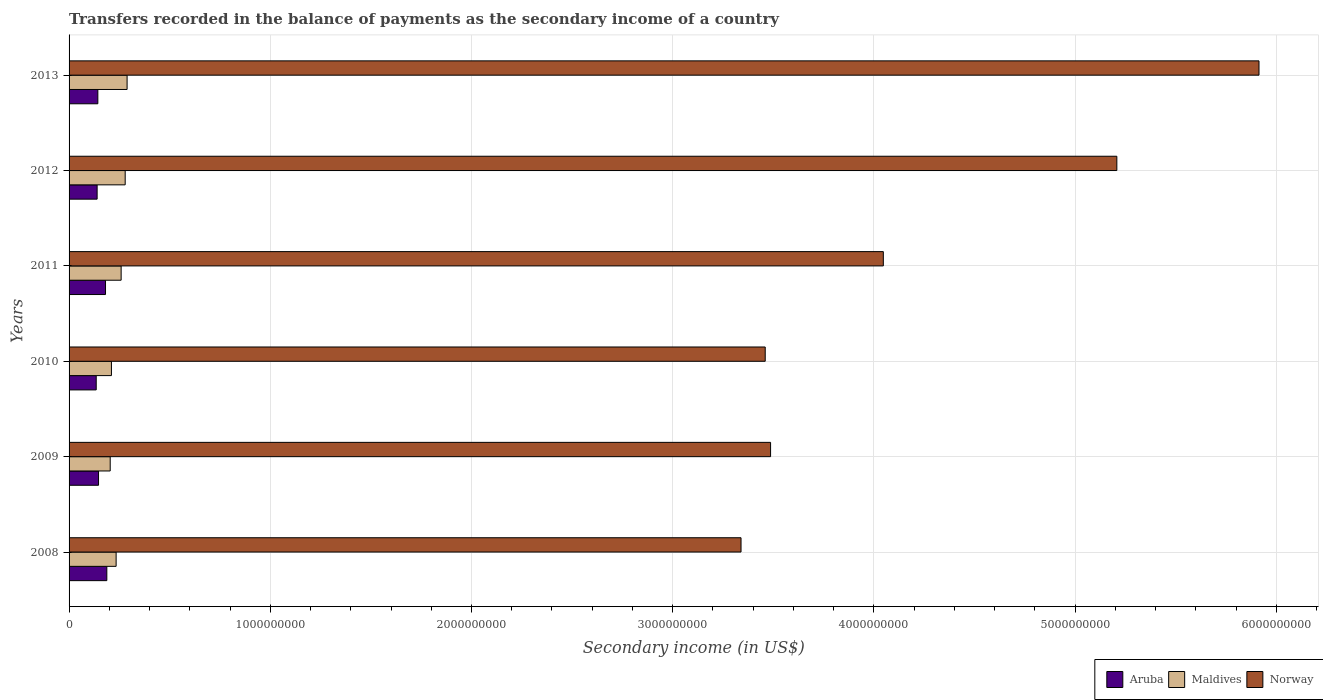Are the number of bars per tick equal to the number of legend labels?
Your response must be concise. Yes. How many bars are there on the 1st tick from the top?
Give a very brief answer. 3. How many bars are there on the 1st tick from the bottom?
Keep it short and to the point. 3. In how many cases, is the number of bars for a given year not equal to the number of legend labels?
Your response must be concise. 0. What is the secondary income of in Norway in 2010?
Provide a succinct answer. 3.46e+09. Across all years, what is the maximum secondary income of in Maldives?
Your response must be concise. 2.88e+08. Across all years, what is the minimum secondary income of in Aruba?
Offer a very short reply. 1.35e+08. In which year was the secondary income of in Maldives maximum?
Offer a terse response. 2013. In which year was the secondary income of in Aruba minimum?
Ensure brevity in your answer.  2010. What is the total secondary income of in Maldives in the graph?
Provide a succinct answer. 1.47e+09. What is the difference between the secondary income of in Aruba in 2008 and that in 2010?
Offer a very short reply. 5.27e+07. What is the difference between the secondary income of in Maldives in 2009 and the secondary income of in Aruba in 2008?
Offer a terse response. 1.68e+07. What is the average secondary income of in Maldives per year?
Your response must be concise. 2.46e+08. In the year 2013, what is the difference between the secondary income of in Maldives and secondary income of in Aruba?
Provide a succinct answer. 1.45e+08. What is the ratio of the secondary income of in Aruba in 2008 to that in 2011?
Provide a short and direct response. 1.04. Is the difference between the secondary income of in Maldives in 2008 and 2009 greater than the difference between the secondary income of in Aruba in 2008 and 2009?
Provide a short and direct response. No. What is the difference between the highest and the second highest secondary income of in Maldives?
Ensure brevity in your answer.  9.48e+06. What is the difference between the highest and the lowest secondary income of in Aruba?
Your response must be concise. 5.27e+07. In how many years, is the secondary income of in Norway greater than the average secondary income of in Norway taken over all years?
Your answer should be very brief. 2. Is the sum of the secondary income of in Aruba in 2012 and 2013 greater than the maximum secondary income of in Maldives across all years?
Offer a very short reply. No. What does the 2nd bar from the top in 2012 represents?
Provide a short and direct response. Maldives. What does the 2nd bar from the bottom in 2012 represents?
Offer a terse response. Maldives. Is it the case that in every year, the sum of the secondary income of in Norway and secondary income of in Maldives is greater than the secondary income of in Aruba?
Keep it short and to the point. Yes. How many years are there in the graph?
Your response must be concise. 6. What is the difference between two consecutive major ticks on the X-axis?
Your response must be concise. 1.00e+09. Does the graph contain grids?
Your answer should be very brief. Yes. Where does the legend appear in the graph?
Your response must be concise. Bottom right. How many legend labels are there?
Keep it short and to the point. 3. How are the legend labels stacked?
Offer a very short reply. Horizontal. What is the title of the graph?
Provide a succinct answer. Transfers recorded in the balance of payments as the secondary income of a country. Does "Turkey" appear as one of the legend labels in the graph?
Your answer should be compact. No. What is the label or title of the X-axis?
Your response must be concise. Secondary income (in US$). What is the Secondary income (in US$) in Aruba in 2008?
Ensure brevity in your answer.  1.88e+08. What is the Secondary income (in US$) in Maldives in 2008?
Ensure brevity in your answer.  2.34e+08. What is the Secondary income (in US$) in Norway in 2008?
Give a very brief answer. 3.34e+09. What is the Secondary income (in US$) of Aruba in 2009?
Make the answer very short. 1.46e+08. What is the Secondary income (in US$) in Maldives in 2009?
Your answer should be very brief. 2.04e+08. What is the Secondary income (in US$) in Norway in 2009?
Offer a very short reply. 3.49e+09. What is the Secondary income (in US$) in Aruba in 2010?
Give a very brief answer. 1.35e+08. What is the Secondary income (in US$) in Maldives in 2010?
Offer a terse response. 2.11e+08. What is the Secondary income (in US$) of Norway in 2010?
Offer a very short reply. 3.46e+09. What is the Secondary income (in US$) in Aruba in 2011?
Offer a very short reply. 1.81e+08. What is the Secondary income (in US$) in Maldives in 2011?
Ensure brevity in your answer.  2.59e+08. What is the Secondary income (in US$) in Norway in 2011?
Your response must be concise. 4.05e+09. What is the Secondary income (in US$) in Aruba in 2012?
Provide a short and direct response. 1.39e+08. What is the Secondary income (in US$) of Maldives in 2012?
Your answer should be very brief. 2.79e+08. What is the Secondary income (in US$) in Norway in 2012?
Give a very brief answer. 5.21e+09. What is the Secondary income (in US$) of Aruba in 2013?
Provide a short and direct response. 1.43e+08. What is the Secondary income (in US$) of Maldives in 2013?
Your response must be concise. 2.88e+08. What is the Secondary income (in US$) in Norway in 2013?
Offer a very short reply. 5.91e+09. Across all years, what is the maximum Secondary income (in US$) of Aruba?
Your response must be concise. 1.88e+08. Across all years, what is the maximum Secondary income (in US$) in Maldives?
Give a very brief answer. 2.88e+08. Across all years, what is the maximum Secondary income (in US$) in Norway?
Provide a short and direct response. 5.91e+09. Across all years, what is the minimum Secondary income (in US$) in Aruba?
Offer a terse response. 1.35e+08. Across all years, what is the minimum Secondary income (in US$) in Maldives?
Your answer should be very brief. 2.04e+08. Across all years, what is the minimum Secondary income (in US$) of Norway?
Your response must be concise. 3.34e+09. What is the total Secondary income (in US$) in Aruba in the graph?
Your answer should be compact. 9.33e+08. What is the total Secondary income (in US$) of Maldives in the graph?
Provide a short and direct response. 1.47e+09. What is the total Secondary income (in US$) in Norway in the graph?
Your answer should be very brief. 2.55e+1. What is the difference between the Secondary income (in US$) of Aruba in 2008 and that in 2009?
Keep it short and to the point. 4.12e+07. What is the difference between the Secondary income (in US$) in Maldives in 2008 and that in 2009?
Your response must be concise. 2.94e+07. What is the difference between the Secondary income (in US$) in Norway in 2008 and that in 2009?
Provide a short and direct response. -1.47e+08. What is the difference between the Secondary income (in US$) in Aruba in 2008 and that in 2010?
Your answer should be very brief. 5.27e+07. What is the difference between the Secondary income (in US$) of Maldives in 2008 and that in 2010?
Offer a very short reply. 2.33e+07. What is the difference between the Secondary income (in US$) in Norway in 2008 and that in 2010?
Provide a short and direct response. -1.20e+08. What is the difference between the Secondary income (in US$) in Aruba in 2008 and that in 2011?
Make the answer very short. 6.54e+06. What is the difference between the Secondary income (in US$) in Maldives in 2008 and that in 2011?
Your answer should be compact. -2.50e+07. What is the difference between the Secondary income (in US$) in Norway in 2008 and that in 2011?
Ensure brevity in your answer.  -7.07e+08. What is the difference between the Secondary income (in US$) in Aruba in 2008 and that in 2012?
Offer a terse response. 4.82e+07. What is the difference between the Secondary income (in US$) of Maldives in 2008 and that in 2012?
Give a very brief answer. -4.51e+07. What is the difference between the Secondary income (in US$) of Norway in 2008 and that in 2012?
Make the answer very short. -1.87e+09. What is the difference between the Secondary income (in US$) in Aruba in 2008 and that in 2013?
Your answer should be compact. 4.46e+07. What is the difference between the Secondary income (in US$) of Maldives in 2008 and that in 2013?
Your answer should be compact. -5.45e+07. What is the difference between the Secondary income (in US$) in Norway in 2008 and that in 2013?
Provide a short and direct response. -2.57e+09. What is the difference between the Secondary income (in US$) of Aruba in 2009 and that in 2010?
Give a very brief answer. 1.15e+07. What is the difference between the Secondary income (in US$) in Maldives in 2009 and that in 2010?
Offer a very short reply. -6.12e+06. What is the difference between the Secondary income (in US$) of Norway in 2009 and that in 2010?
Give a very brief answer. 2.66e+07. What is the difference between the Secondary income (in US$) in Aruba in 2009 and that in 2011?
Make the answer very short. -3.47e+07. What is the difference between the Secondary income (in US$) of Maldives in 2009 and that in 2011?
Provide a short and direct response. -5.44e+07. What is the difference between the Secondary income (in US$) of Norway in 2009 and that in 2011?
Offer a terse response. -5.60e+08. What is the difference between the Secondary income (in US$) of Aruba in 2009 and that in 2012?
Make the answer very short. 6.98e+06. What is the difference between the Secondary income (in US$) of Maldives in 2009 and that in 2012?
Give a very brief answer. -7.45e+07. What is the difference between the Secondary income (in US$) of Norway in 2009 and that in 2012?
Make the answer very short. -1.72e+09. What is the difference between the Secondary income (in US$) of Aruba in 2009 and that in 2013?
Your response must be concise. 3.41e+06. What is the difference between the Secondary income (in US$) of Maldives in 2009 and that in 2013?
Give a very brief answer. -8.40e+07. What is the difference between the Secondary income (in US$) in Norway in 2009 and that in 2013?
Your answer should be very brief. -2.43e+09. What is the difference between the Secondary income (in US$) of Aruba in 2010 and that in 2011?
Ensure brevity in your answer.  -4.62e+07. What is the difference between the Secondary income (in US$) in Maldives in 2010 and that in 2011?
Make the answer very short. -4.83e+07. What is the difference between the Secondary income (in US$) in Norway in 2010 and that in 2011?
Your answer should be compact. -5.87e+08. What is the difference between the Secondary income (in US$) of Aruba in 2010 and that in 2012?
Offer a very short reply. -4.53e+06. What is the difference between the Secondary income (in US$) of Maldives in 2010 and that in 2012?
Provide a succinct answer. -6.84e+07. What is the difference between the Secondary income (in US$) in Norway in 2010 and that in 2012?
Your answer should be compact. -1.75e+09. What is the difference between the Secondary income (in US$) in Aruba in 2010 and that in 2013?
Your answer should be compact. -8.10e+06. What is the difference between the Secondary income (in US$) of Maldives in 2010 and that in 2013?
Your answer should be compact. -7.79e+07. What is the difference between the Secondary income (in US$) in Norway in 2010 and that in 2013?
Offer a terse response. -2.45e+09. What is the difference between the Secondary income (in US$) in Aruba in 2011 and that in 2012?
Your answer should be very brief. 4.17e+07. What is the difference between the Secondary income (in US$) in Maldives in 2011 and that in 2012?
Provide a short and direct response. -2.01e+07. What is the difference between the Secondary income (in US$) in Norway in 2011 and that in 2012?
Offer a very short reply. -1.16e+09. What is the difference between the Secondary income (in US$) in Aruba in 2011 and that in 2013?
Your answer should be compact. 3.81e+07. What is the difference between the Secondary income (in US$) of Maldives in 2011 and that in 2013?
Provide a short and direct response. -2.96e+07. What is the difference between the Secondary income (in US$) in Norway in 2011 and that in 2013?
Make the answer very short. -1.87e+09. What is the difference between the Secondary income (in US$) in Aruba in 2012 and that in 2013?
Provide a short and direct response. -3.58e+06. What is the difference between the Secondary income (in US$) in Maldives in 2012 and that in 2013?
Keep it short and to the point. -9.48e+06. What is the difference between the Secondary income (in US$) of Norway in 2012 and that in 2013?
Make the answer very short. -7.07e+08. What is the difference between the Secondary income (in US$) of Aruba in 2008 and the Secondary income (in US$) of Maldives in 2009?
Provide a succinct answer. -1.68e+07. What is the difference between the Secondary income (in US$) of Aruba in 2008 and the Secondary income (in US$) of Norway in 2009?
Your answer should be very brief. -3.30e+09. What is the difference between the Secondary income (in US$) of Maldives in 2008 and the Secondary income (in US$) of Norway in 2009?
Offer a terse response. -3.25e+09. What is the difference between the Secondary income (in US$) in Aruba in 2008 and the Secondary income (in US$) in Maldives in 2010?
Offer a terse response. -2.29e+07. What is the difference between the Secondary income (in US$) of Aruba in 2008 and the Secondary income (in US$) of Norway in 2010?
Provide a succinct answer. -3.27e+09. What is the difference between the Secondary income (in US$) of Maldives in 2008 and the Secondary income (in US$) of Norway in 2010?
Your answer should be very brief. -3.23e+09. What is the difference between the Secondary income (in US$) in Aruba in 2008 and the Secondary income (in US$) in Maldives in 2011?
Ensure brevity in your answer.  -7.12e+07. What is the difference between the Secondary income (in US$) in Aruba in 2008 and the Secondary income (in US$) in Norway in 2011?
Your response must be concise. -3.86e+09. What is the difference between the Secondary income (in US$) of Maldives in 2008 and the Secondary income (in US$) of Norway in 2011?
Offer a terse response. -3.81e+09. What is the difference between the Secondary income (in US$) in Aruba in 2008 and the Secondary income (in US$) in Maldives in 2012?
Give a very brief answer. -9.13e+07. What is the difference between the Secondary income (in US$) in Aruba in 2008 and the Secondary income (in US$) in Norway in 2012?
Provide a short and direct response. -5.02e+09. What is the difference between the Secondary income (in US$) in Maldives in 2008 and the Secondary income (in US$) in Norway in 2012?
Make the answer very short. -4.97e+09. What is the difference between the Secondary income (in US$) in Aruba in 2008 and the Secondary income (in US$) in Maldives in 2013?
Your answer should be very brief. -1.01e+08. What is the difference between the Secondary income (in US$) of Aruba in 2008 and the Secondary income (in US$) of Norway in 2013?
Give a very brief answer. -5.73e+09. What is the difference between the Secondary income (in US$) of Maldives in 2008 and the Secondary income (in US$) of Norway in 2013?
Offer a very short reply. -5.68e+09. What is the difference between the Secondary income (in US$) in Aruba in 2009 and the Secondary income (in US$) in Maldives in 2010?
Your response must be concise. -6.41e+07. What is the difference between the Secondary income (in US$) in Aruba in 2009 and the Secondary income (in US$) in Norway in 2010?
Your answer should be very brief. -3.31e+09. What is the difference between the Secondary income (in US$) in Maldives in 2009 and the Secondary income (in US$) in Norway in 2010?
Offer a very short reply. -3.26e+09. What is the difference between the Secondary income (in US$) of Aruba in 2009 and the Secondary income (in US$) of Maldives in 2011?
Provide a succinct answer. -1.12e+08. What is the difference between the Secondary income (in US$) of Aruba in 2009 and the Secondary income (in US$) of Norway in 2011?
Provide a short and direct response. -3.90e+09. What is the difference between the Secondary income (in US$) of Maldives in 2009 and the Secondary income (in US$) of Norway in 2011?
Ensure brevity in your answer.  -3.84e+09. What is the difference between the Secondary income (in US$) of Aruba in 2009 and the Secondary income (in US$) of Maldives in 2012?
Provide a short and direct response. -1.32e+08. What is the difference between the Secondary income (in US$) in Aruba in 2009 and the Secondary income (in US$) in Norway in 2012?
Your answer should be very brief. -5.06e+09. What is the difference between the Secondary income (in US$) of Maldives in 2009 and the Secondary income (in US$) of Norway in 2012?
Make the answer very short. -5.00e+09. What is the difference between the Secondary income (in US$) of Aruba in 2009 and the Secondary income (in US$) of Maldives in 2013?
Make the answer very short. -1.42e+08. What is the difference between the Secondary income (in US$) of Aruba in 2009 and the Secondary income (in US$) of Norway in 2013?
Your response must be concise. -5.77e+09. What is the difference between the Secondary income (in US$) in Maldives in 2009 and the Secondary income (in US$) in Norway in 2013?
Your answer should be compact. -5.71e+09. What is the difference between the Secondary income (in US$) in Aruba in 2010 and the Secondary income (in US$) in Maldives in 2011?
Provide a short and direct response. -1.24e+08. What is the difference between the Secondary income (in US$) of Aruba in 2010 and the Secondary income (in US$) of Norway in 2011?
Offer a terse response. -3.91e+09. What is the difference between the Secondary income (in US$) in Maldives in 2010 and the Secondary income (in US$) in Norway in 2011?
Ensure brevity in your answer.  -3.84e+09. What is the difference between the Secondary income (in US$) of Aruba in 2010 and the Secondary income (in US$) of Maldives in 2012?
Your response must be concise. -1.44e+08. What is the difference between the Secondary income (in US$) of Aruba in 2010 and the Secondary income (in US$) of Norway in 2012?
Your answer should be compact. -5.07e+09. What is the difference between the Secondary income (in US$) of Maldives in 2010 and the Secondary income (in US$) of Norway in 2012?
Your answer should be very brief. -5.00e+09. What is the difference between the Secondary income (in US$) in Aruba in 2010 and the Secondary income (in US$) in Maldives in 2013?
Ensure brevity in your answer.  -1.53e+08. What is the difference between the Secondary income (in US$) in Aruba in 2010 and the Secondary income (in US$) in Norway in 2013?
Provide a succinct answer. -5.78e+09. What is the difference between the Secondary income (in US$) of Maldives in 2010 and the Secondary income (in US$) of Norway in 2013?
Your answer should be compact. -5.70e+09. What is the difference between the Secondary income (in US$) in Aruba in 2011 and the Secondary income (in US$) in Maldives in 2012?
Keep it short and to the point. -9.78e+07. What is the difference between the Secondary income (in US$) of Aruba in 2011 and the Secondary income (in US$) of Norway in 2012?
Offer a very short reply. -5.03e+09. What is the difference between the Secondary income (in US$) of Maldives in 2011 and the Secondary income (in US$) of Norway in 2012?
Make the answer very short. -4.95e+09. What is the difference between the Secondary income (in US$) of Aruba in 2011 and the Secondary income (in US$) of Maldives in 2013?
Your answer should be very brief. -1.07e+08. What is the difference between the Secondary income (in US$) in Aruba in 2011 and the Secondary income (in US$) in Norway in 2013?
Your answer should be compact. -5.73e+09. What is the difference between the Secondary income (in US$) in Maldives in 2011 and the Secondary income (in US$) in Norway in 2013?
Your answer should be very brief. -5.66e+09. What is the difference between the Secondary income (in US$) in Aruba in 2012 and the Secondary income (in US$) in Maldives in 2013?
Make the answer very short. -1.49e+08. What is the difference between the Secondary income (in US$) in Aruba in 2012 and the Secondary income (in US$) in Norway in 2013?
Your answer should be very brief. -5.77e+09. What is the difference between the Secondary income (in US$) of Maldives in 2012 and the Secondary income (in US$) of Norway in 2013?
Your response must be concise. -5.64e+09. What is the average Secondary income (in US$) of Aruba per year?
Make the answer very short. 1.55e+08. What is the average Secondary income (in US$) of Maldives per year?
Keep it short and to the point. 2.46e+08. What is the average Secondary income (in US$) of Norway per year?
Provide a short and direct response. 4.24e+09. In the year 2008, what is the difference between the Secondary income (in US$) in Aruba and Secondary income (in US$) in Maldives?
Your answer should be compact. -4.62e+07. In the year 2008, what is the difference between the Secondary income (in US$) in Aruba and Secondary income (in US$) in Norway?
Your answer should be very brief. -3.15e+09. In the year 2008, what is the difference between the Secondary income (in US$) of Maldives and Secondary income (in US$) of Norway?
Make the answer very short. -3.11e+09. In the year 2009, what is the difference between the Secondary income (in US$) in Aruba and Secondary income (in US$) in Maldives?
Give a very brief answer. -5.80e+07. In the year 2009, what is the difference between the Secondary income (in US$) of Aruba and Secondary income (in US$) of Norway?
Offer a terse response. -3.34e+09. In the year 2009, what is the difference between the Secondary income (in US$) of Maldives and Secondary income (in US$) of Norway?
Your answer should be very brief. -3.28e+09. In the year 2010, what is the difference between the Secondary income (in US$) of Aruba and Secondary income (in US$) of Maldives?
Offer a terse response. -7.56e+07. In the year 2010, what is the difference between the Secondary income (in US$) of Aruba and Secondary income (in US$) of Norway?
Give a very brief answer. -3.33e+09. In the year 2010, what is the difference between the Secondary income (in US$) of Maldives and Secondary income (in US$) of Norway?
Offer a terse response. -3.25e+09. In the year 2011, what is the difference between the Secondary income (in US$) of Aruba and Secondary income (in US$) of Maldives?
Your response must be concise. -7.77e+07. In the year 2011, what is the difference between the Secondary income (in US$) of Aruba and Secondary income (in US$) of Norway?
Offer a terse response. -3.87e+09. In the year 2011, what is the difference between the Secondary income (in US$) of Maldives and Secondary income (in US$) of Norway?
Your answer should be compact. -3.79e+09. In the year 2012, what is the difference between the Secondary income (in US$) of Aruba and Secondary income (in US$) of Maldives?
Your response must be concise. -1.39e+08. In the year 2012, what is the difference between the Secondary income (in US$) in Aruba and Secondary income (in US$) in Norway?
Provide a succinct answer. -5.07e+09. In the year 2012, what is the difference between the Secondary income (in US$) of Maldives and Secondary income (in US$) of Norway?
Provide a succinct answer. -4.93e+09. In the year 2013, what is the difference between the Secondary income (in US$) in Aruba and Secondary income (in US$) in Maldives?
Offer a terse response. -1.45e+08. In the year 2013, what is the difference between the Secondary income (in US$) in Aruba and Secondary income (in US$) in Norway?
Your answer should be very brief. -5.77e+09. In the year 2013, what is the difference between the Secondary income (in US$) of Maldives and Secondary income (in US$) of Norway?
Offer a very short reply. -5.63e+09. What is the ratio of the Secondary income (in US$) of Aruba in 2008 to that in 2009?
Keep it short and to the point. 1.28. What is the ratio of the Secondary income (in US$) of Maldives in 2008 to that in 2009?
Provide a short and direct response. 1.14. What is the ratio of the Secondary income (in US$) of Norway in 2008 to that in 2009?
Provide a succinct answer. 0.96. What is the ratio of the Secondary income (in US$) in Aruba in 2008 to that in 2010?
Ensure brevity in your answer.  1.39. What is the ratio of the Secondary income (in US$) in Maldives in 2008 to that in 2010?
Provide a short and direct response. 1.11. What is the ratio of the Secondary income (in US$) of Norway in 2008 to that in 2010?
Give a very brief answer. 0.97. What is the ratio of the Secondary income (in US$) of Aruba in 2008 to that in 2011?
Offer a very short reply. 1.04. What is the ratio of the Secondary income (in US$) in Maldives in 2008 to that in 2011?
Give a very brief answer. 0.9. What is the ratio of the Secondary income (in US$) in Norway in 2008 to that in 2011?
Your response must be concise. 0.83. What is the ratio of the Secondary income (in US$) in Aruba in 2008 to that in 2012?
Offer a terse response. 1.35. What is the ratio of the Secondary income (in US$) of Maldives in 2008 to that in 2012?
Ensure brevity in your answer.  0.84. What is the ratio of the Secondary income (in US$) of Norway in 2008 to that in 2012?
Keep it short and to the point. 0.64. What is the ratio of the Secondary income (in US$) in Aruba in 2008 to that in 2013?
Your response must be concise. 1.31. What is the ratio of the Secondary income (in US$) of Maldives in 2008 to that in 2013?
Provide a short and direct response. 0.81. What is the ratio of the Secondary income (in US$) of Norway in 2008 to that in 2013?
Your answer should be compact. 0.56. What is the ratio of the Secondary income (in US$) of Aruba in 2009 to that in 2010?
Give a very brief answer. 1.09. What is the ratio of the Secondary income (in US$) in Maldives in 2009 to that in 2010?
Give a very brief answer. 0.97. What is the ratio of the Secondary income (in US$) of Norway in 2009 to that in 2010?
Keep it short and to the point. 1.01. What is the ratio of the Secondary income (in US$) of Aruba in 2009 to that in 2011?
Give a very brief answer. 0.81. What is the ratio of the Secondary income (in US$) of Maldives in 2009 to that in 2011?
Make the answer very short. 0.79. What is the ratio of the Secondary income (in US$) in Norway in 2009 to that in 2011?
Give a very brief answer. 0.86. What is the ratio of the Secondary income (in US$) in Aruba in 2009 to that in 2012?
Provide a short and direct response. 1.05. What is the ratio of the Secondary income (in US$) of Maldives in 2009 to that in 2012?
Offer a very short reply. 0.73. What is the ratio of the Secondary income (in US$) of Norway in 2009 to that in 2012?
Provide a succinct answer. 0.67. What is the ratio of the Secondary income (in US$) of Aruba in 2009 to that in 2013?
Provide a succinct answer. 1.02. What is the ratio of the Secondary income (in US$) in Maldives in 2009 to that in 2013?
Make the answer very short. 0.71. What is the ratio of the Secondary income (in US$) in Norway in 2009 to that in 2013?
Provide a short and direct response. 0.59. What is the ratio of the Secondary income (in US$) of Aruba in 2010 to that in 2011?
Your response must be concise. 0.74. What is the ratio of the Secondary income (in US$) of Maldives in 2010 to that in 2011?
Provide a succinct answer. 0.81. What is the ratio of the Secondary income (in US$) in Norway in 2010 to that in 2011?
Your answer should be very brief. 0.85. What is the ratio of the Secondary income (in US$) in Aruba in 2010 to that in 2012?
Your answer should be compact. 0.97. What is the ratio of the Secondary income (in US$) in Maldives in 2010 to that in 2012?
Make the answer very short. 0.75. What is the ratio of the Secondary income (in US$) of Norway in 2010 to that in 2012?
Offer a terse response. 0.66. What is the ratio of the Secondary income (in US$) in Aruba in 2010 to that in 2013?
Ensure brevity in your answer.  0.94. What is the ratio of the Secondary income (in US$) in Maldives in 2010 to that in 2013?
Provide a succinct answer. 0.73. What is the ratio of the Secondary income (in US$) of Norway in 2010 to that in 2013?
Offer a terse response. 0.58. What is the ratio of the Secondary income (in US$) in Aruba in 2011 to that in 2012?
Your answer should be compact. 1.3. What is the ratio of the Secondary income (in US$) in Maldives in 2011 to that in 2012?
Your answer should be very brief. 0.93. What is the ratio of the Secondary income (in US$) of Norway in 2011 to that in 2012?
Your answer should be very brief. 0.78. What is the ratio of the Secondary income (in US$) of Aruba in 2011 to that in 2013?
Give a very brief answer. 1.27. What is the ratio of the Secondary income (in US$) of Maldives in 2011 to that in 2013?
Give a very brief answer. 0.9. What is the ratio of the Secondary income (in US$) in Norway in 2011 to that in 2013?
Provide a short and direct response. 0.68. What is the ratio of the Secondary income (in US$) in Maldives in 2012 to that in 2013?
Your answer should be compact. 0.97. What is the ratio of the Secondary income (in US$) in Norway in 2012 to that in 2013?
Your response must be concise. 0.88. What is the difference between the highest and the second highest Secondary income (in US$) in Aruba?
Offer a very short reply. 6.54e+06. What is the difference between the highest and the second highest Secondary income (in US$) of Maldives?
Your response must be concise. 9.48e+06. What is the difference between the highest and the second highest Secondary income (in US$) in Norway?
Your answer should be compact. 7.07e+08. What is the difference between the highest and the lowest Secondary income (in US$) of Aruba?
Provide a succinct answer. 5.27e+07. What is the difference between the highest and the lowest Secondary income (in US$) in Maldives?
Provide a succinct answer. 8.40e+07. What is the difference between the highest and the lowest Secondary income (in US$) in Norway?
Offer a terse response. 2.57e+09. 